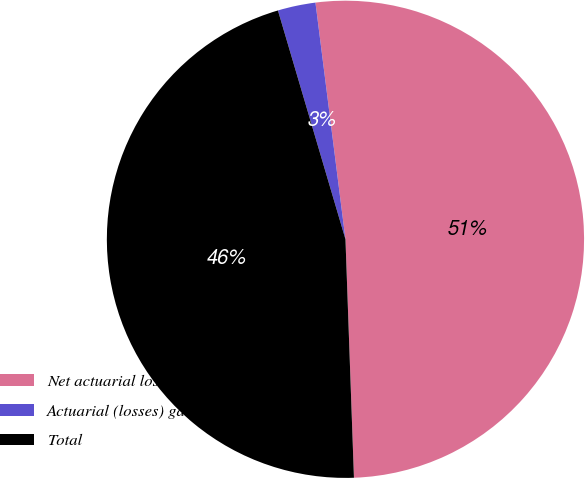Convert chart. <chart><loc_0><loc_0><loc_500><loc_500><pie_chart><fcel>Net actuarial losses (gains)<fcel>Actuarial (losses) gains<fcel>Total<nl><fcel>51.44%<fcel>2.56%<fcel>46.0%<nl></chart> 